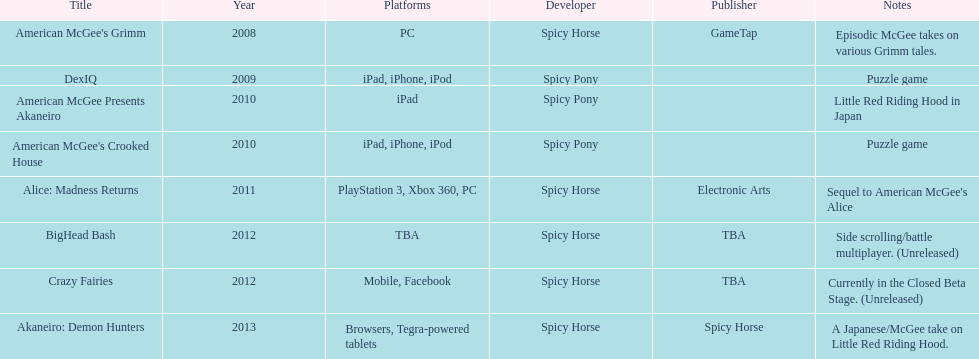Which year witnessed the release of a total of 2 titles? 2010. 